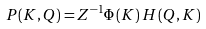Convert formula to latex. <formula><loc_0><loc_0><loc_500><loc_500>P ( K , Q ) = Z ^ { - 1 } \Phi \left ( K \right ) H \left ( Q , K \right )</formula> 